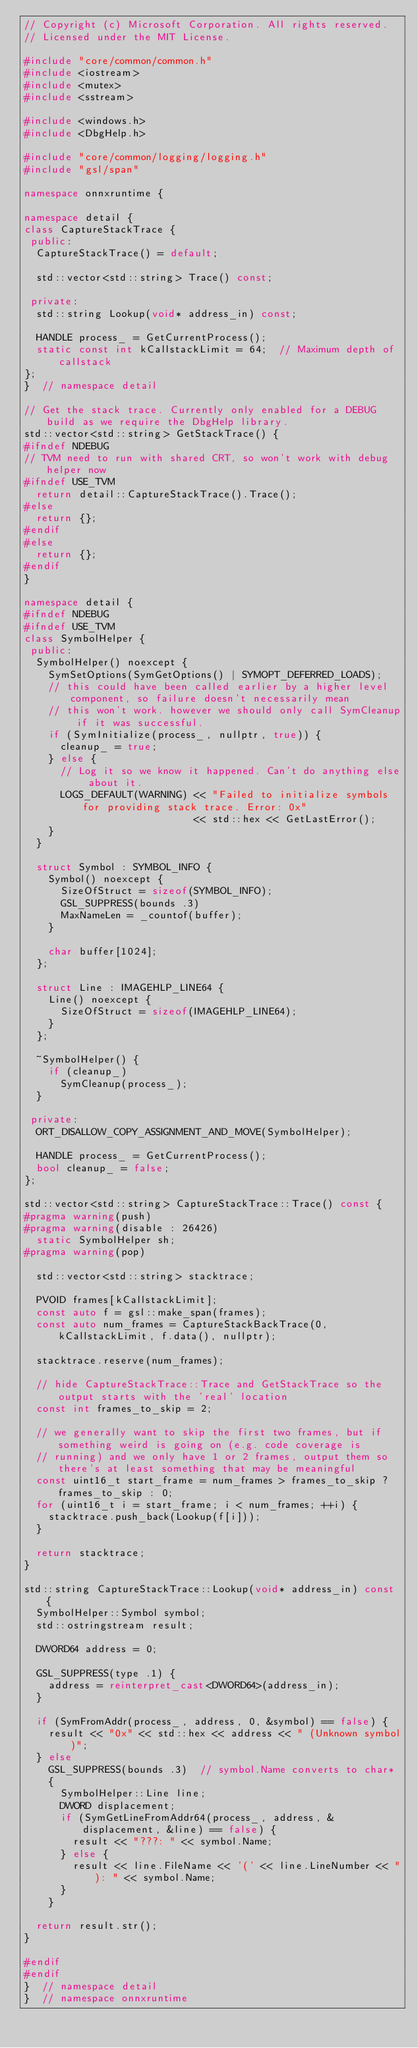Convert code to text. <code><loc_0><loc_0><loc_500><loc_500><_C++_>// Copyright (c) Microsoft Corporation. All rights reserved.
// Licensed under the MIT License.

#include "core/common/common.h"
#include <iostream>
#include <mutex>
#include <sstream>

#include <windows.h>
#include <DbgHelp.h>

#include "core/common/logging/logging.h"
#include "gsl/span"

namespace onnxruntime {

namespace detail {
class CaptureStackTrace {
 public:
  CaptureStackTrace() = default;

  std::vector<std::string> Trace() const;

 private:
  std::string Lookup(void* address_in) const;

  HANDLE process_ = GetCurrentProcess();
  static const int kCallstackLimit = 64;  // Maximum depth of callstack
};
}  // namespace detail

// Get the stack trace. Currently only enabled for a DEBUG build as we require the DbgHelp library.
std::vector<std::string> GetStackTrace() {
#ifndef NDEBUG
// TVM need to run with shared CRT, so won't work with debug helper now
#ifndef USE_TVM
  return detail::CaptureStackTrace().Trace();
#else
  return {};
#endif
#else
  return {};
#endif
}

namespace detail {
#ifndef NDEBUG
#ifndef USE_TVM
class SymbolHelper {
 public:
  SymbolHelper() noexcept {
    SymSetOptions(SymGetOptions() | SYMOPT_DEFERRED_LOADS);
    // this could have been called earlier by a higher level component, so failure doesn't necessarily mean
    // this won't work. however we should only call SymCleanup if it was successful.
    if (SymInitialize(process_, nullptr, true)) {
      cleanup_ = true;
    } else {
      // Log it so we know it happened. Can't do anything else about it.
      LOGS_DEFAULT(WARNING) << "Failed to initialize symbols for providing stack trace. Error: 0x"
                            << std::hex << GetLastError();
    }
  }

  struct Symbol : SYMBOL_INFO {
    Symbol() noexcept {
      SizeOfStruct = sizeof(SYMBOL_INFO);
      GSL_SUPPRESS(bounds .3)
      MaxNameLen = _countof(buffer);
    }

    char buffer[1024];
  };

  struct Line : IMAGEHLP_LINE64 {
    Line() noexcept {
      SizeOfStruct = sizeof(IMAGEHLP_LINE64);
    }
  };

  ~SymbolHelper() {
    if (cleanup_)
      SymCleanup(process_);
  }

 private:
  ORT_DISALLOW_COPY_ASSIGNMENT_AND_MOVE(SymbolHelper);

  HANDLE process_ = GetCurrentProcess();
  bool cleanup_ = false;
};

std::vector<std::string> CaptureStackTrace::Trace() const {
#pragma warning(push)
#pragma warning(disable : 26426)
  static SymbolHelper sh;
#pragma warning(pop)

  std::vector<std::string> stacktrace;

  PVOID frames[kCallstackLimit];
  const auto f = gsl::make_span(frames);
  const auto num_frames = CaptureStackBackTrace(0, kCallstackLimit, f.data(), nullptr);

  stacktrace.reserve(num_frames);

  // hide CaptureStackTrace::Trace and GetStackTrace so the output starts with the 'real' location
  const int frames_to_skip = 2;

  // we generally want to skip the first two frames, but if something weird is going on (e.g. code coverage is
  // running) and we only have 1 or 2 frames, output them so there's at least something that may be meaningful
  const uint16_t start_frame = num_frames > frames_to_skip ? frames_to_skip : 0;
  for (uint16_t i = start_frame; i < num_frames; ++i) {
    stacktrace.push_back(Lookup(f[i]));
  }

  return stacktrace;
}

std::string CaptureStackTrace::Lookup(void* address_in) const {
  SymbolHelper::Symbol symbol;
  std::ostringstream result;

  DWORD64 address = 0;

  GSL_SUPPRESS(type .1) {
    address = reinterpret_cast<DWORD64>(address_in);
  }

  if (SymFromAddr(process_, address, 0, &symbol) == false) {
    result << "0x" << std::hex << address << " (Unknown symbol)";
  } else
    GSL_SUPPRESS(bounds .3)  // symbol.Name converts to char*
    {
      SymbolHelper::Line line;
      DWORD displacement;
      if (SymGetLineFromAddr64(process_, address, &displacement, &line) == false) {
        result << "???: " << symbol.Name;
      } else {
        result << line.FileName << '(' << line.LineNumber << "): " << symbol.Name;
      }
    }

  return result.str();
}

#endif
#endif
}  // namespace detail
}  // namespace onnxruntime
</code> 